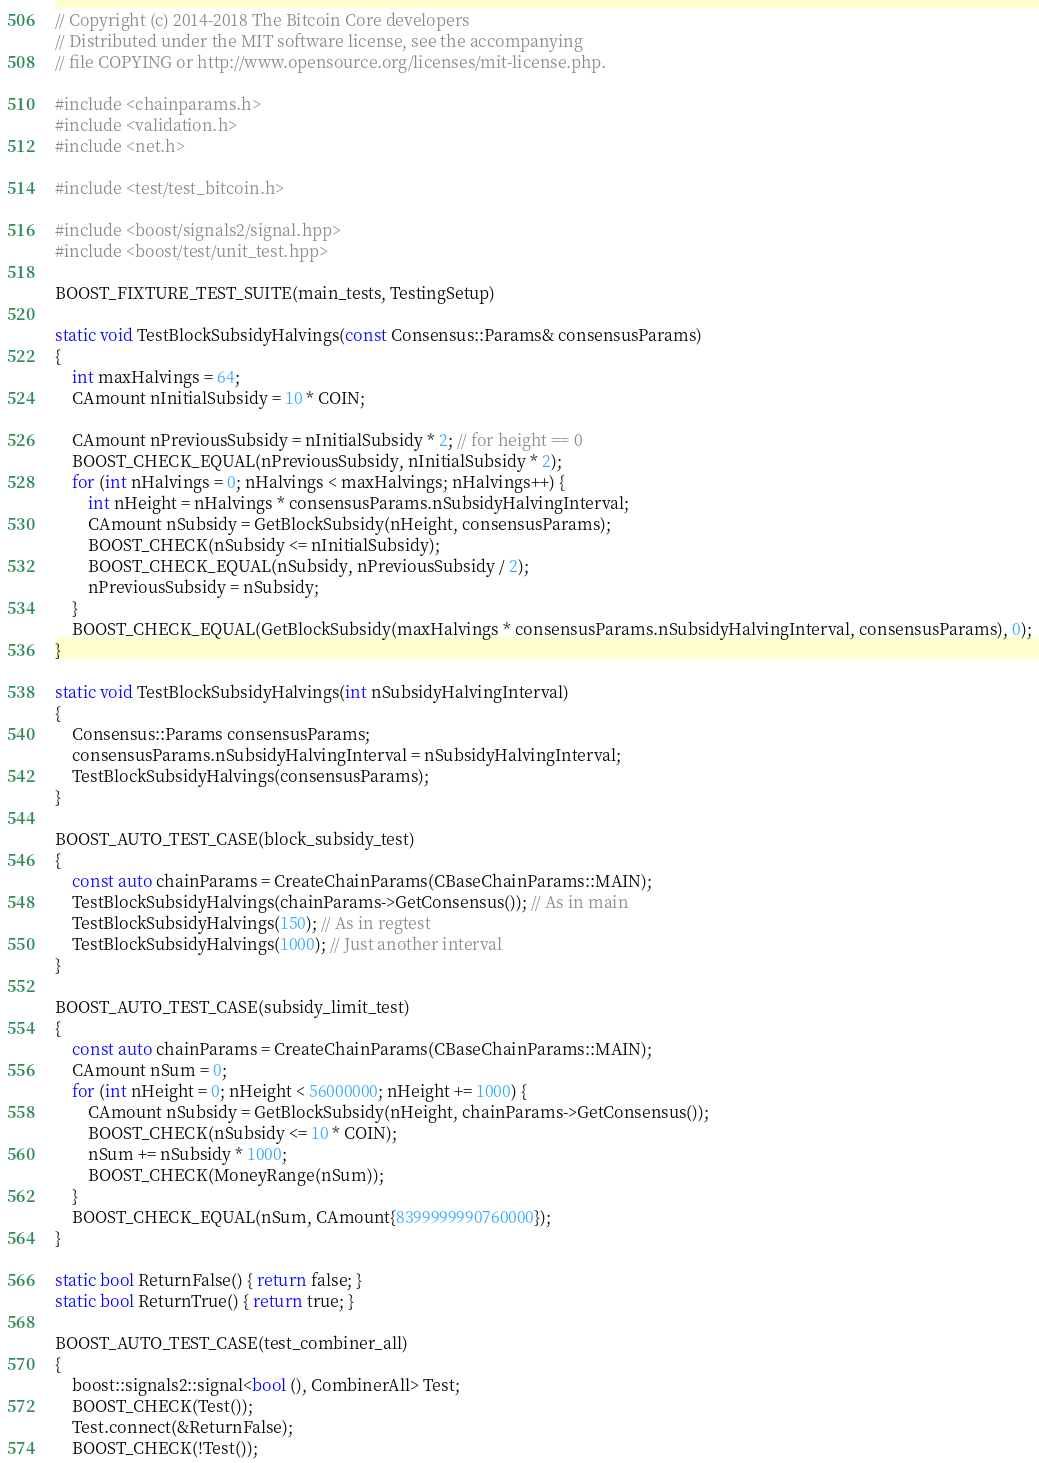Convert code to text. <code><loc_0><loc_0><loc_500><loc_500><_C++_>// Copyright (c) 2014-2018 The Bitcoin Core developers
// Distributed under the MIT software license, see the accompanying
// file COPYING or http://www.opensource.org/licenses/mit-license.php.

#include <chainparams.h>
#include <validation.h>
#include <net.h>

#include <test/test_bitcoin.h>

#include <boost/signals2/signal.hpp>
#include <boost/test/unit_test.hpp>

BOOST_FIXTURE_TEST_SUITE(main_tests, TestingSetup)

static void TestBlockSubsidyHalvings(const Consensus::Params& consensusParams)
{
    int maxHalvings = 64;
    CAmount nInitialSubsidy = 10 * COIN;

    CAmount nPreviousSubsidy = nInitialSubsidy * 2; // for height == 0
    BOOST_CHECK_EQUAL(nPreviousSubsidy, nInitialSubsidy * 2);
    for (int nHalvings = 0; nHalvings < maxHalvings; nHalvings++) {
        int nHeight = nHalvings * consensusParams.nSubsidyHalvingInterval;
        CAmount nSubsidy = GetBlockSubsidy(nHeight, consensusParams);
        BOOST_CHECK(nSubsidy <= nInitialSubsidy);
        BOOST_CHECK_EQUAL(nSubsidy, nPreviousSubsidy / 2);
        nPreviousSubsidy = nSubsidy;
    }
    BOOST_CHECK_EQUAL(GetBlockSubsidy(maxHalvings * consensusParams.nSubsidyHalvingInterval, consensusParams), 0);
}

static void TestBlockSubsidyHalvings(int nSubsidyHalvingInterval)
{
    Consensus::Params consensusParams;
    consensusParams.nSubsidyHalvingInterval = nSubsidyHalvingInterval;
    TestBlockSubsidyHalvings(consensusParams);
}

BOOST_AUTO_TEST_CASE(block_subsidy_test)
{
    const auto chainParams = CreateChainParams(CBaseChainParams::MAIN);
    TestBlockSubsidyHalvings(chainParams->GetConsensus()); // As in main
    TestBlockSubsidyHalvings(150); // As in regtest
    TestBlockSubsidyHalvings(1000); // Just another interval
}

BOOST_AUTO_TEST_CASE(subsidy_limit_test)
{
    const auto chainParams = CreateChainParams(CBaseChainParams::MAIN);
    CAmount nSum = 0;
    for (int nHeight = 0; nHeight < 56000000; nHeight += 1000) {
        CAmount nSubsidy = GetBlockSubsidy(nHeight, chainParams->GetConsensus());
        BOOST_CHECK(nSubsidy <= 10 * COIN);
        nSum += nSubsidy * 1000;
        BOOST_CHECK(MoneyRange(nSum));
    }
    BOOST_CHECK_EQUAL(nSum, CAmount{8399999990760000});
}

static bool ReturnFalse() { return false; }
static bool ReturnTrue() { return true; }

BOOST_AUTO_TEST_CASE(test_combiner_all)
{
    boost::signals2::signal<bool (), CombinerAll> Test;
    BOOST_CHECK(Test());
    Test.connect(&ReturnFalse);
    BOOST_CHECK(!Test());</code> 